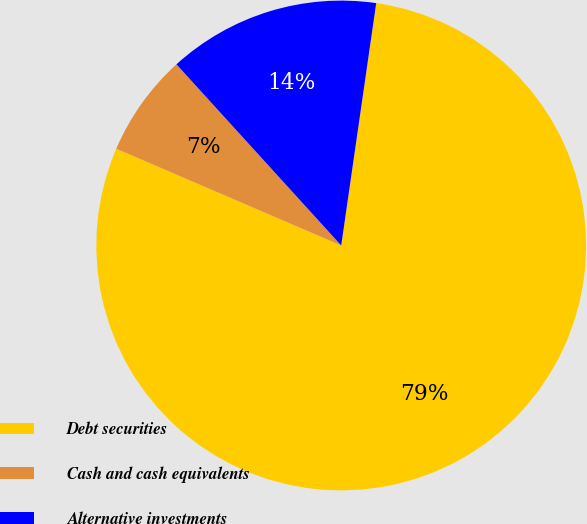<chart> <loc_0><loc_0><loc_500><loc_500><pie_chart><fcel>Debt securities<fcel>Cash and cash equivalents<fcel>Alternative investments<nl><fcel>79.19%<fcel>6.79%<fcel>14.03%<nl></chart> 